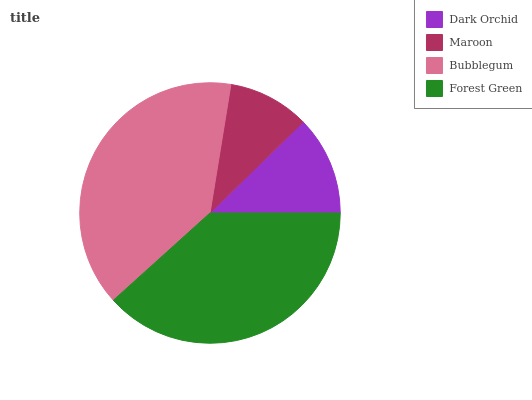Is Maroon the minimum?
Answer yes or no. Yes. Is Bubblegum the maximum?
Answer yes or no. Yes. Is Bubblegum the minimum?
Answer yes or no. No. Is Maroon the maximum?
Answer yes or no. No. Is Bubblegum greater than Maroon?
Answer yes or no. Yes. Is Maroon less than Bubblegum?
Answer yes or no. Yes. Is Maroon greater than Bubblegum?
Answer yes or no. No. Is Bubblegum less than Maroon?
Answer yes or no. No. Is Forest Green the high median?
Answer yes or no. Yes. Is Dark Orchid the low median?
Answer yes or no. Yes. Is Dark Orchid the high median?
Answer yes or no. No. Is Maroon the low median?
Answer yes or no. No. 